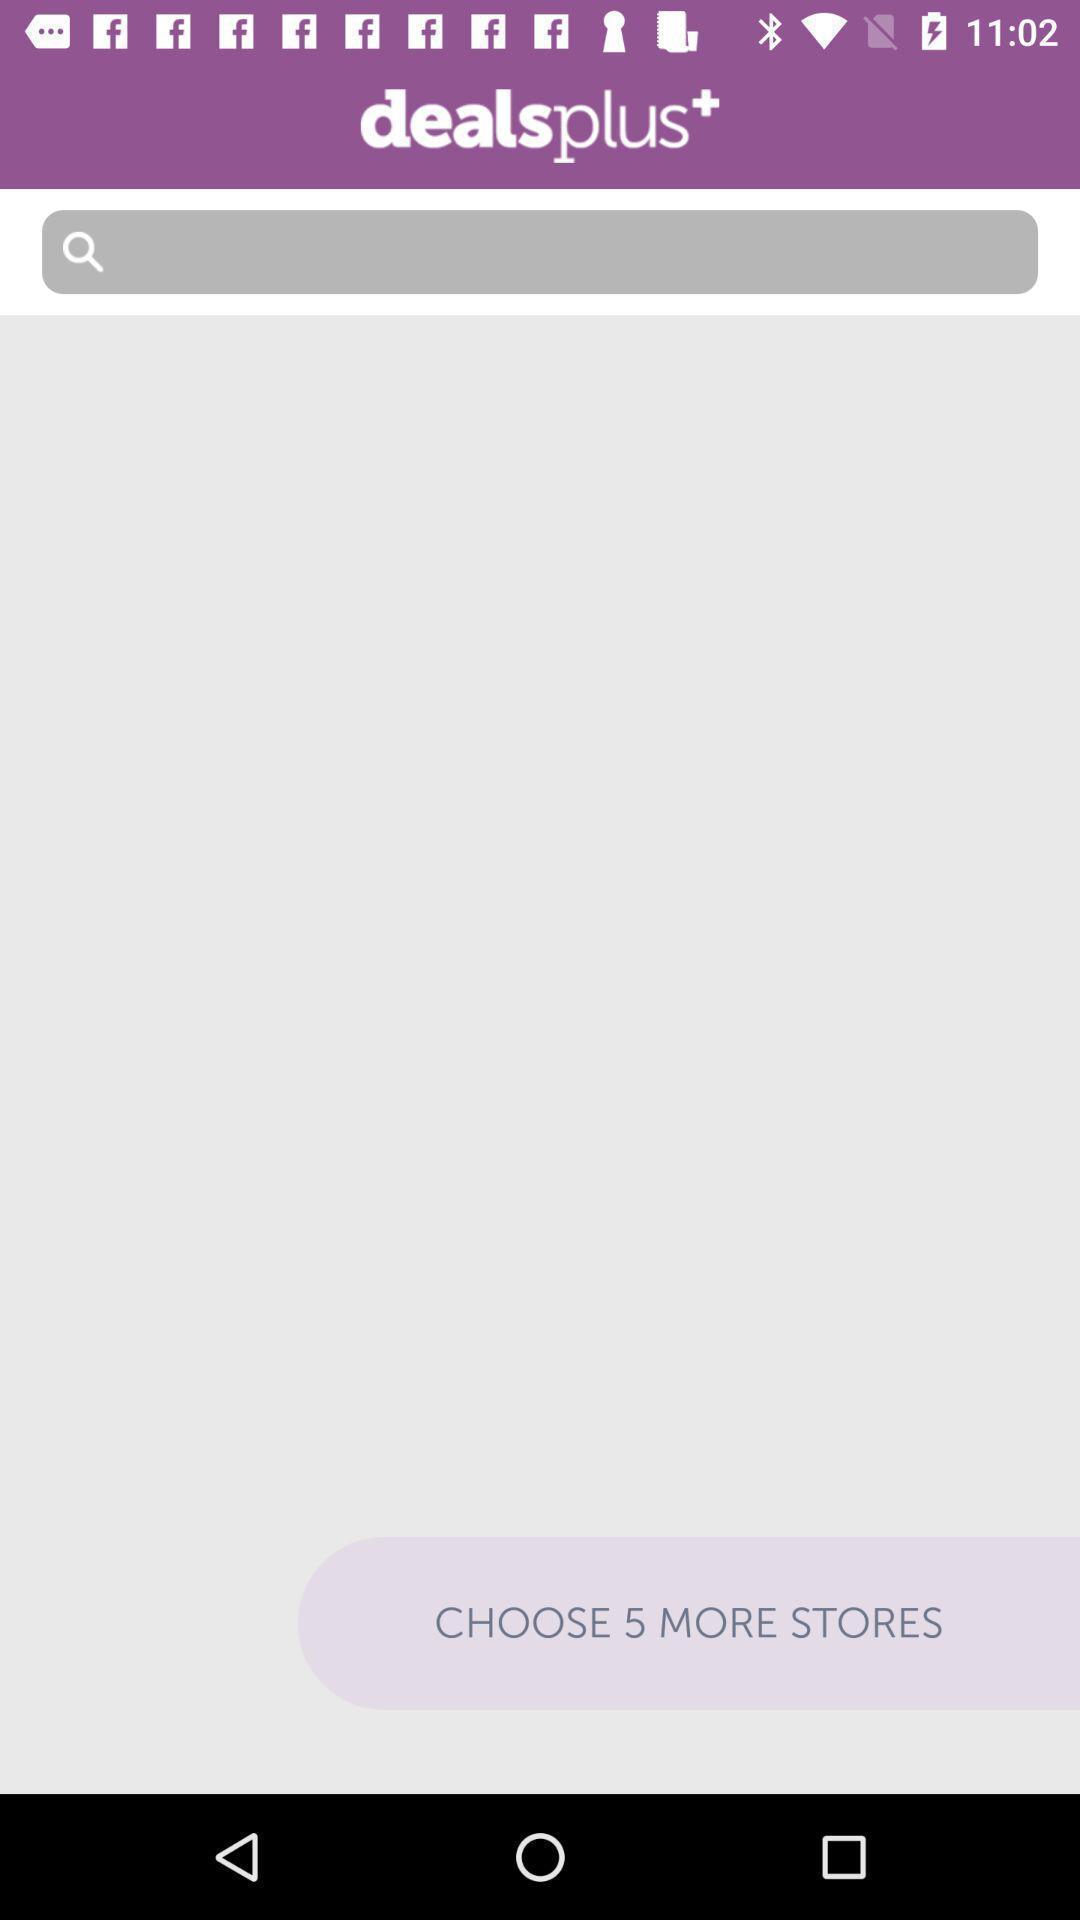Summarize the information in this screenshot. Search page to find the stores. 